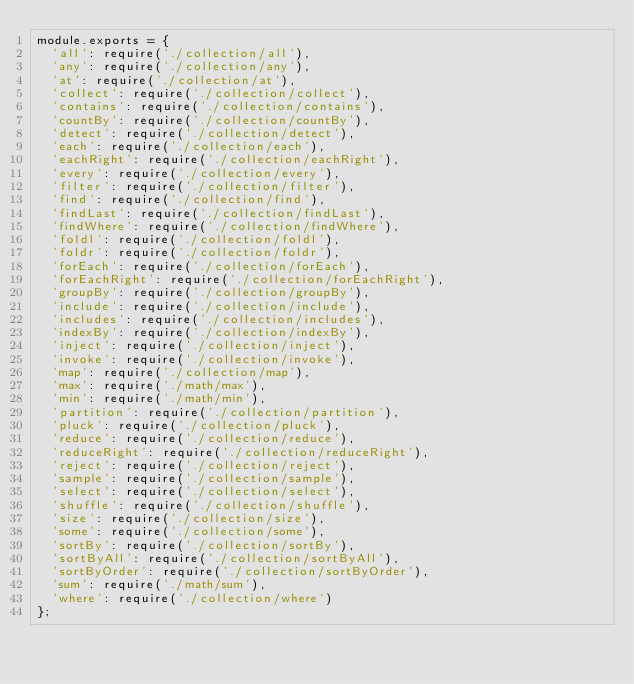Convert code to text. <code><loc_0><loc_0><loc_500><loc_500><_JavaScript_>module.exports = {
  'all': require('./collection/all'),
  'any': require('./collection/any'),
  'at': require('./collection/at'),
  'collect': require('./collection/collect'),
  'contains': require('./collection/contains'),
  'countBy': require('./collection/countBy'),
  'detect': require('./collection/detect'),
  'each': require('./collection/each'),
  'eachRight': require('./collection/eachRight'),
  'every': require('./collection/every'),
  'filter': require('./collection/filter'),
  'find': require('./collection/find'),
  'findLast': require('./collection/findLast'),
  'findWhere': require('./collection/findWhere'),
  'foldl': require('./collection/foldl'),
  'foldr': require('./collection/foldr'),
  'forEach': require('./collection/forEach'),
  'forEachRight': require('./collection/forEachRight'),
  'groupBy': require('./collection/groupBy'),
  'include': require('./collection/include'),
  'includes': require('./collection/includes'),
  'indexBy': require('./collection/indexBy'),
  'inject': require('./collection/inject'),
  'invoke': require('./collection/invoke'),
  'map': require('./collection/map'),
  'max': require('./math/max'),
  'min': require('./math/min'),
  'partition': require('./collection/partition'),
  'pluck': require('./collection/pluck'),
  'reduce': require('./collection/reduce'),
  'reduceRight': require('./collection/reduceRight'),
  'reject': require('./collection/reject'),
  'sample': require('./collection/sample'),
  'select': require('./collection/select'),
  'shuffle': require('./collection/shuffle'),
  'size': require('./collection/size'),
  'some': require('./collection/some'),
  'sortBy': require('./collection/sortBy'),
  'sortByAll': require('./collection/sortByAll'),
  'sortByOrder': require('./collection/sortByOrder'),
  'sum': require('./math/sum'),
  'where': require('./collection/where')
};
</code> 